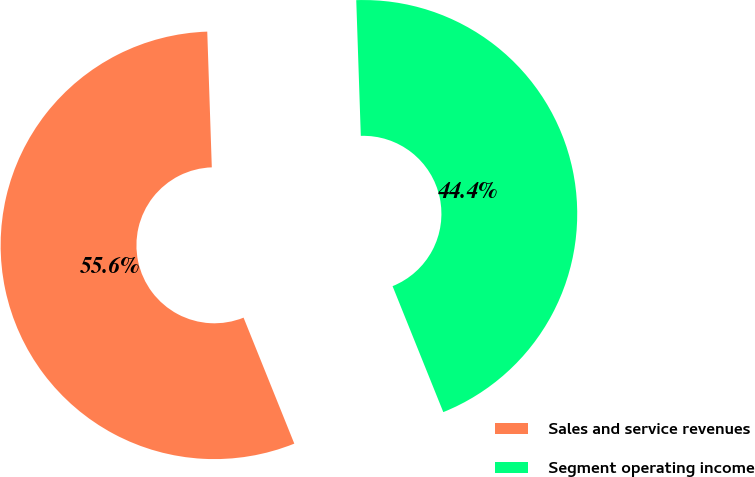<chart> <loc_0><loc_0><loc_500><loc_500><pie_chart><fcel>Sales and service revenues<fcel>Segment operating income<nl><fcel>55.56%<fcel>44.44%<nl></chart> 